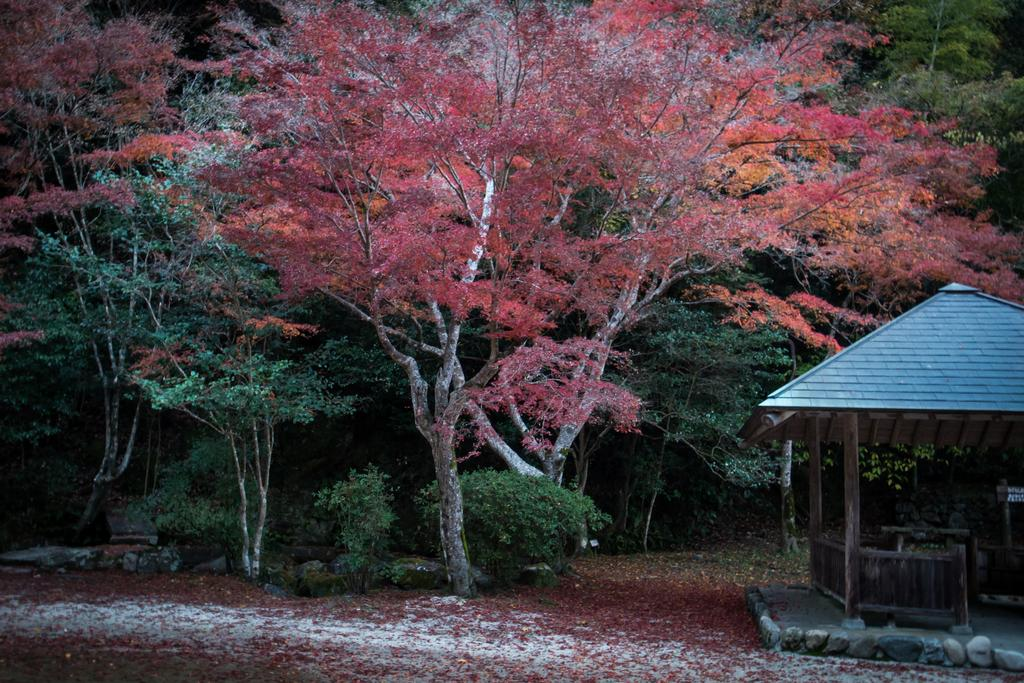What type of natural elements are present in the image? There is a group of trees and plants in the image. Where is the shed located in the image? The shed is on the right side of the image. What part of the plants can be seen at the bottom of the image? Leaves are visible at the bottom of the image. What type of jelly can be seen on the leaves in the image? There is no jelly present on the leaves in the image; only leaves are visible. What type of garden is featured in the image? The image does not show a garden; it features a group of trees and plants, along with a shed. 